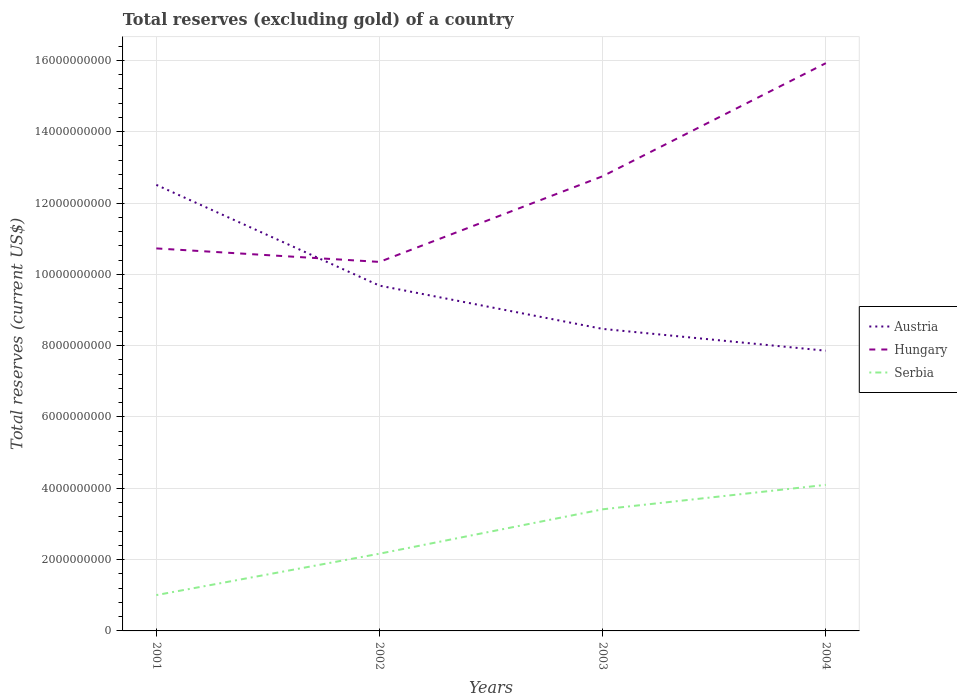How many different coloured lines are there?
Offer a very short reply. 3. Does the line corresponding to Hungary intersect with the line corresponding to Austria?
Give a very brief answer. Yes. Is the number of lines equal to the number of legend labels?
Make the answer very short. Yes. Across all years, what is the maximum total reserves (excluding gold) in Serbia?
Ensure brevity in your answer.  1.00e+09. In which year was the total reserves (excluding gold) in Serbia maximum?
Provide a succinct answer. 2001. What is the total total reserves (excluding gold) in Hungary in the graph?
Make the answer very short. -2.40e+09. What is the difference between the highest and the second highest total reserves (excluding gold) in Serbia?
Provide a short and direct response. 3.09e+09. What is the difference between two consecutive major ticks on the Y-axis?
Ensure brevity in your answer.  2.00e+09. Where does the legend appear in the graph?
Your response must be concise. Center right. How many legend labels are there?
Your response must be concise. 3. What is the title of the graph?
Provide a short and direct response. Total reserves (excluding gold) of a country. Does "Cabo Verde" appear as one of the legend labels in the graph?
Ensure brevity in your answer.  No. What is the label or title of the X-axis?
Ensure brevity in your answer.  Years. What is the label or title of the Y-axis?
Provide a succinct answer. Total reserves (current US$). What is the Total reserves (current US$) of Austria in 2001?
Your answer should be compact. 1.25e+1. What is the Total reserves (current US$) in Hungary in 2001?
Offer a terse response. 1.07e+1. What is the Total reserves (current US$) of Serbia in 2001?
Provide a short and direct response. 1.00e+09. What is the Total reserves (current US$) in Austria in 2002?
Provide a short and direct response. 9.68e+09. What is the Total reserves (current US$) of Hungary in 2002?
Your answer should be compact. 1.03e+1. What is the Total reserves (current US$) of Serbia in 2002?
Offer a very short reply. 2.17e+09. What is the Total reserves (current US$) in Austria in 2003?
Your response must be concise. 8.47e+09. What is the Total reserves (current US$) in Hungary in 2003?
Your response must be concise. 1.28e+1. What is the Total reserves (current US$) in Serbia in 2003?
Ensure brevity in your answer.  3.41e+09. What is the Total reserves (current US$) in Austria in 2004?
Your response must be concise. 7.86e+09. What is the Total reserves (current US$) in Hungary in 2004?
Provide a succinct answer. 1.59e+1. What is the Total reserves (current US$) of Serbia in 2004?
Provide a succinct answer. 4.10e+09. Across all years, what is the maximum Total reserves (current US$) in Austria?
Your answer should be compact. 1.25e+1. Across all years, what is the maximum Total reserves (current US$) in Hungary?
Your answer should be very brief. 1.59e+1. Across all years, what is the maximum Total reserves (current US$) of Serbia?
Offer a very short reply. 4.10e+09. Across all years, what is the minimum Total reserves (current US$) of Austria?
Your answer should be compact. 7.86e+09. Across all years, what is the minimum Total reserves (current US$) of Hungary?
Your answer should be very brief. 1.03e+1. Across all years, what is the minimum Total reserves (current US$) of Serbia?
Make the answer very short. 1.00e+09. What is the total Total reserves (current US$) in Austria in the graph?
Your answer should be compact. 3.85e+1. What is the total Total reserves (current US$) of Hungary in the graph?
Your response must be concise. 4.97e+1. What is the total Total reserves (current US$) of Serbia in the graph?
Keep it short and to the point. 1.07e+1. What is the difference between the Total reserves (current US$) of Austria in 2001 and that in 2002?
Give a very brief answer. 2.83e+09. What is the difference between the Total reserves (current US$) in Hungary in 2001 and that in 2002?
Your answer should be compact. 3.79e+08. What is the difference between the Total reserves (current US$) of Serbia in 2001 and that in 2002?
Make the answer very short. -1.16e+09. What is the difference between the Total reserves (current US$) of Austria in 2001 and that in 2003?
Your response must be concise. 4.04e+09. What is the difference between the Total reserves (current US$) in Hungary in 2001 and that in 2003?
Offer a terse response. -2.02e+09. What is the difference between the Total reserves (current US$) of Serbia in 2001 and that in 2003?
Keep it short and to the point. -2.41e+09. What is the difference between the Total reserves (current US$) in Austria in 2001 and that in 2004?
Ensure brevity in your answer.  4.65e+09. What is the difference between the Total reserves (current US$) of Hungary in 2001 and that in 2004?
Your answer should be compact. -5.19e+09. What is the difference between the Total reserves (current US$) in Serbia in 2001 and that in 2004?
Your answer should be very brief. -3.09e+09. What is the difference between the Total reserves (current US$) in Austria in 2002 and that in 2003?
Your answer should be compact. 1.21e+09. What is the difference between the Total reserves (current US$) of Hungary in 2002 and that in 2003?
Provide a short and direct response. -2.40e+09. What is the difference between the Total reserves (current US$) of Serbia in 2002 and that in 2003?
Your answer should be very brief. -1.24e+09. What is the difference between the Total reserves (current US$) in Austria in 2002 and that in 2004?
Your answer should be very brief. 1.82e+09. What is the difference between the Total reserves (current US$) in Hungary in 2002 and that in 2004?
Offer a terse response. -5.57e+09. What is the difference between the Total reserves (current US$) in Serbia in 2002 and that in 2004?
Keep it short and to the point. -1.93e+09. What is the difference between the Total reserves (current US$) in Austria in 2003 and that in 2004?
Give a very brief answer. 6.12e+08. What is the difference between the Total reserves (current US$) of Hungary in 2003 and that in 2004?
Make the answer very short. -3.17e+09. What is the difference between the Total reserves (current US$) of Serbia in 2003 and that in 2004?
Your answer should be very brief. -6.85e+08. What is the difference between the Total reserves (current US$) of Austria in 2001 and the Total reserves (current US$) of Hungary in 2002?
Your answer should be compact. 2.16e+09. What is the difference between the Total reserves (current US$) in Austria in 2001 and the Total reserves (current US$) in Serbia in 2002?
Your answer should be very brief. 1.03e+1. What is the difference between the Total reserves (current US$) of Hungary in 2001 and the Total reserves (current US$) of Serbia in 2002?
Your response must be concise. 8.56e+09. What is the difference between the Total reserves (current US$) in Austria in 2001 and the Total reserves (current US$) in Hungary in 2003?
Make the answer very short. -2.42e+08. What is the difference between the Total reserves (current US$) of Austria in 2001 and the Total reserves (current US$) of Serbia in 2003?
Provide a succinct answer. 9.10e+09. What is the difference between the Total reserves (current US$) of Hungary in 2001 and the Total reserves (current US$) of Serbia in 2003?
Offer a terse response. 7.32e+09. What is the difference between the Total reserves (current US$) in Austria in 2001 and the Total reserves (current US$) in Hungary in 2004?
Ensure brevity in your answer.  -3.41e+09. What is the difference between the Total reserves (current US$) in Austria in 2001 and the Total reserves (current US$) in Serbia in 2004?
Your answer should be compact. 8.41e+09. What is the difference between the Total reserves (current US$) in Hungary in 2001 and the Total reserves (current US$) in Serbia in 2004?
Ensure brevity in your answer.  6.63e+09. What is the difference between the Total reserves (current US$) of Austria in 2002 and the Total reserves (current US$) of Hungary in 2003?
Make the answer very short. -3.07e+09. What is the difference between the Total reserves (current US$) of Austria in 2002 and the Total reserves (current US$) of Serbia in 2003?
Keep it short and to the point. 6.27e+09. What is the difference between the Total reserves (current US$) in Hungary in 2002 and the Total reserves (current US$) in Serbia in 2003?
Offer a very short reply. 6.94e+09. What is the difference between the Total reserves (current US$) in Austria in 2002 and the Total reserves (current US$) in Hungary in 2004?
Your answer should be compact. -6.24e+09. What is the difference between the Total reserves (current US$) of Austria in 2002 and the Total reserves (current US$) of Serbia in 2004?
Ensure brevity in your answer.  5.59e+09. What is the difference between the Total reserves (current US$) in Hungary in 2002 and the Total reserves (current US$) in Serbia in 2004?
Provide a short and direct response. 6.25e+09. What is the difference between the Total reserves (current US$) in Austria in 2003 and the Total reserves (current US$) in Hungary in 2004?
Keep it short and to the point. -7.45e+09. What is the difference between the Total reserves (current US$) of Austria in 2003 and the Total reserves (current US$) of Serbia in 2004?
Make the answer very short. 4.37e+09. What is the difference between the Total reserves (current US$) of Hungary in 2003 and the Total reserves (current US$) of Serbia in 2004?
Provide a succinct answer. 8.66e+09. What is the average Total reserves (current US$) of Austria per year?
Your response must be concise. 9.63e+09. What is the average Total reserves (current US$) in Hungary per year?
Your answer should be very brief. 1.24e+1. What is the average Total reserves (current US$) in Serbia per year?
Your answer should be compact. 2.67e+09. In the year 2001, what is the difference between the Total reserves (current US$) of Austria and Total reserves (current US$) of Hungary?
Give a very brief answer. 1.78e+09. In the year 2001, what is the difference between the Total reserves (current US$) of Austria and Total reserves (current US$) of Serbia?
Your response must be concise. 1.15e+1. In the year 2001, what is the difference between the Total reserves (current US$) of Hungary and Total reserves (current US$) of Serbia?
Your response must be concise. 9.72e+09. In the year 2002, what is the difference between the Total reserves (current US$) of Austria and Total reserves (current US$) of Hungary?
Your answer should be compact. -6.65e+08. In the year 2002, what is the difference between the Total reserves (current US$) in Austria and Total reserves (current US$) in Serbia?
Your response must be concise. 7.52e+09. In the year 2002, what is the difference between the Total reserves (current US$) of Hungary and Total reserves (current US$) of Serbia?
Offer a very short reply. 8.18e+09. In the year 2003, what is the difference between the Total reserves (current US$) in Austria and Total reserves (current US$) in Hungary?
Your answer should be very brief. -4.28e+09. In the year 2003, what is the difference between the Total reserves (current US$) of Austria and Total reserves (current US$) of Serbia?
Provide a succinct answer. 5.06e+09. In the year 2003, what is the difference between the Total reserves (current US$) in Hungary and Total reserves (current US$) in Serbia?
Offer a very short reply. 9.34e+09. In the year 2004, what is the difference between the Total reserves (current US$) of Austria and Total reserves (current US$) of Hungary?
Give a very brief answer. -8.06e+09. In the year 2004, what is the difference between the Total reserves (current US$) of Austria and Total reserves (current US$) of Serbia?
Your response must be concise. 3.76e+09. In the year 2004, what is the difference between the Total reserves (current US$) of Hungary and Total reserves (current US$) of Serbia?
Give a very brief answer. 1.18e+1. What is the ratio of the Total reserves (current US$) of Austria in 2001 to that in 2002?
Make the answer very short. 1.29. What is the ratio of the Total reserves (current US$) in Hungary in 2001 to that in 2002?
Your answer should be very brief. 1.04. What is the ratio of the Total reserves (current US$) in Serbia in 2001 to that in 2002?
Offer a very short reply. 0.46. What is the ratio of the Total reserves (current US$) in Austria in 2001 to that in 2003?
Your response must be concise. 1.48. What is the ratio of the Total reserves (current US$) of Hungary in 2001 to that in 2003?
Make the answer very short. 0.84. What is the ratio of the Total reserves (current US$) in Serbia in 2001 to that in 2003?
Make the answer very short. 0.29. What is the ratio of the Total reserves (current US$) in Austria in 2001 to that in 2004?
Provide a succinct answer. 1.59. What is the ratio of the Total reserves (current US$) in Hungary in 2001 to that in 2004?
Offer a very short reply. 0.67. What is the ratio of the Total reserves (current US$) in Serbia in 2001 to that in 2004?
Make the answer very short. 0.25. What is the ratio of the Total reserves (current US$) of Austria in 2002 to that in 2003?
Provide a succinct answer. 1.14. What is the ratio of the Total reserves (current US$) in Hungary in 2002 to that in 2003?
Give a very brief answer. 0.81. What is the ratio of the Total reserves (current US$) of Serbia in 2002 to that in 2003?
Your answer should be compact. 0.64. What is the ratio of the Total reserves (current US$) in Austria in 2002 to that in 2004?
Offer a terse response. 1.23. What is the ratio of the Total reserves (current US$) of Hungary in 2002 to that in 2004?
Offer a terse response. 0.65. What is the ratio of the Total reserves (current US$) of Serbia in 2002 to that in 2004?
Your answer should be compact. 0.53. What is the ratio of the Total reserves (current US$) of Austria in 2003 to that in 2004?
Keep it short and to the point. 1.08. What is the ratio of the Total reserves (current US$) of Hungary in 2003 to that in 2004?
Your response must be concise. 0.8. What is the ratio of the Total reserves (current US$) of Serbia in 2003 to that in 2004?
Offer a very short reply. 0.83. What is the difference between the highest and the second highest Total reserves (current US$) of Austria?
Offer a very short reply. 2.83e+09. What is the difference between the highest and the second highest Total reserves (current US$) in Hungary?
Give a very brief answer. 3.17e+09. What is the difference between the highest and the second highest Total reserves (current US$) of Serbia?
Provide a succinct answer. 6.85e+08. What is the difference between the highest and the lowest Total reserves (current US$) of Austria?
Offer a terse response. 4.65e+09. What is the difference between the highest and the lowest Total reserves (current US$) in Hungary?
Your response must be concise. 5.57e+09. What is the difference between the highest and the lowest Total reserves (current US$) in Serbia?
Make the answer very short. 3.09e+09. 